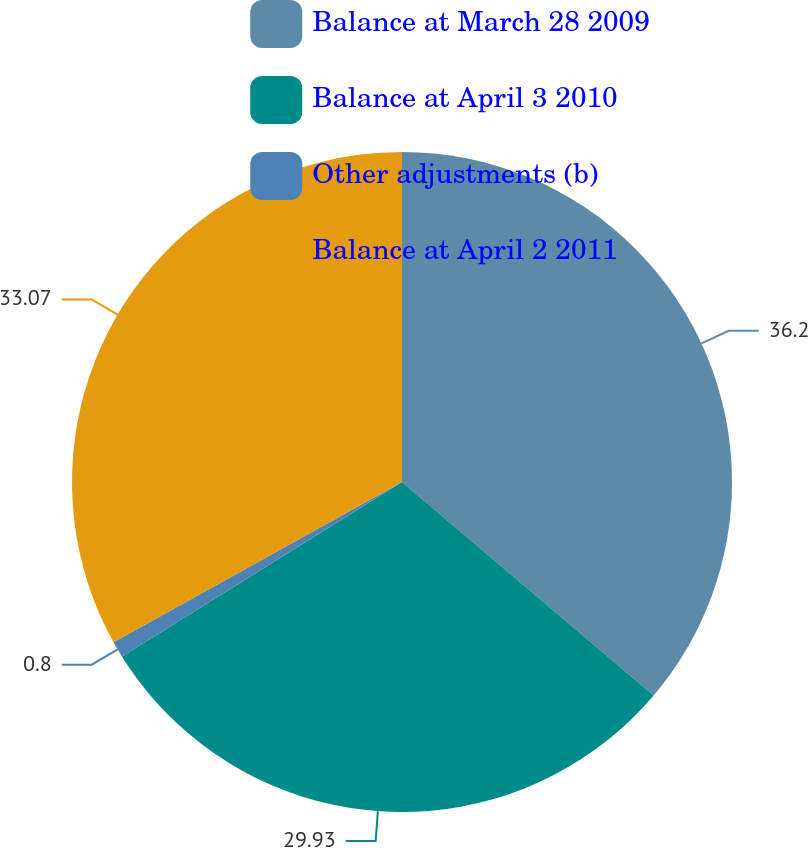Convert chart to OTSL. <chart><loc_0><loc_0><loc_500><loc_500><pie_chart><fcel>Balance at March 28 2009<fcel>Balance at April 3 2010<fcel>Other adjustments (b)<fcel>Balance at April 2 2011<nl><fcel>36.2%<fcel>29.93%<fcel>0.8%<fcel>33.07%<nl></chart> 